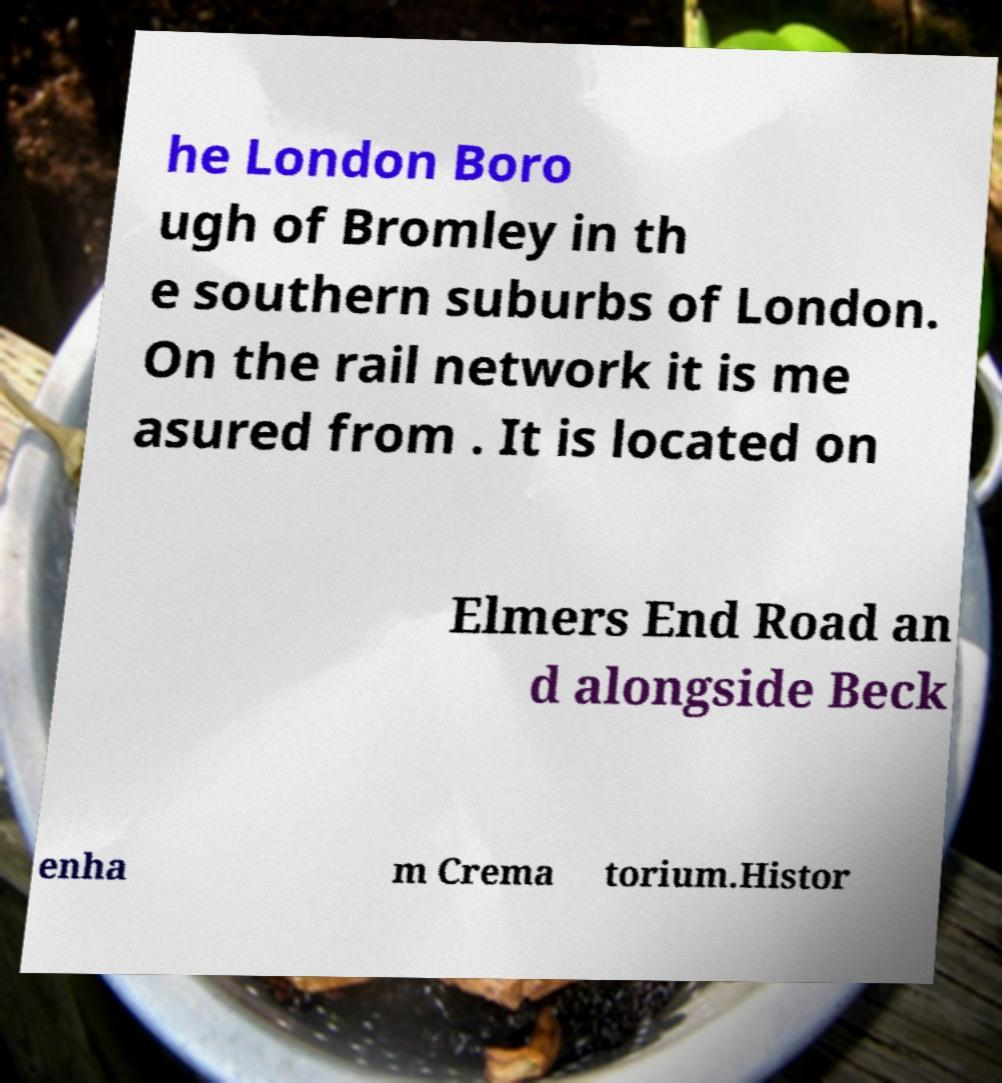Please read and relay the text visible in this image. What does it say? he London Boro ugh of Bromley in th e southern suburbs of London. On the rail network it is me asured from . It is located on Elmers End Road an d alongside Beck enha m Crema torium.Histor 